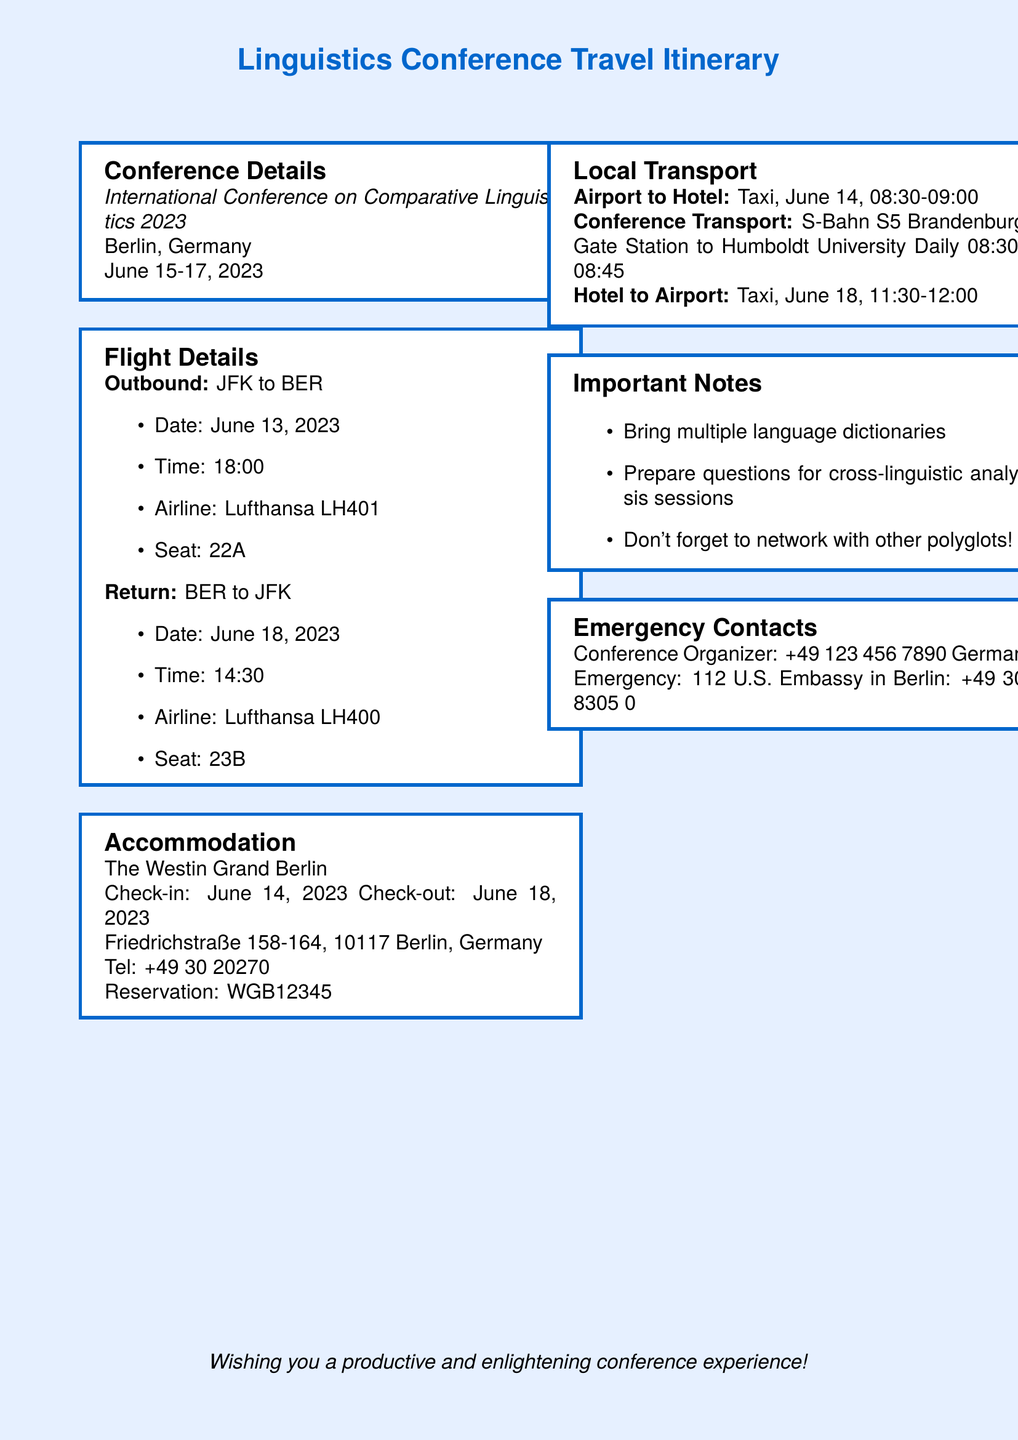What is the date of the conference? The date of the conference is listed as June 15-17, 2023.
Answer: June 15-17, 2023 What is the airline for the outbound flight? The airline for the outbound flight is mentioned under flight details.
Answer: Lufthansa What is the check-in date for the hotel? The check-in date for the hotel is specified in the accommodation section.
Answer: June 14, 2023 What type of transport is arranged from the airport to the hotel? The type of transport is specified in the local transport section.
Answer: Taxi What is the reservation number for the hotel? The reservation number is stated in the accommodation details.
Answer: WGB12345 Why is it important to bring multiple language dictionaries? This pertains to networking effectively and having resources during the conference, as emphasized in the important notes.
Answer: To prepare for cross-linguistic analysis sessions Which train line is used for conference transport? This information can be found under local transport.
Answer: S-Bahn S5 What time is the return flight? The return flight time is provided in the flight details section.
Answer: 14:30 What is the emergency number for the U.S. Embassy in Berlin? The emergency number is listed in the emergency contacts section.
Answer: +49 30 8305 0 